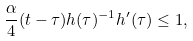<formula> <loc_0><loc_0><loc_500><loc_500>\frac { \alpha } { 4 } ( t - \tau ) h ( \tau ) ^ { - 1 } h ^ { \prime } ( \tau ) \leq 1 ,</formula> 